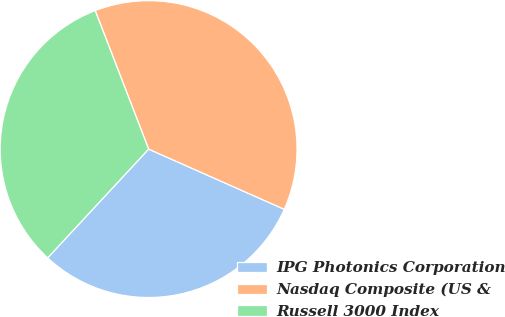Convert chart. <chart><loc_0><loc_0><loc_500><loc_500><pie_chart><fcel>IPG Photonics Corporation<fcel>Nasdaq Composite (US &<fcel>Russell 3000 Index<nl><fcel>30.26%<fcel>37.51%<fcel>32.23%<nl></chart> 